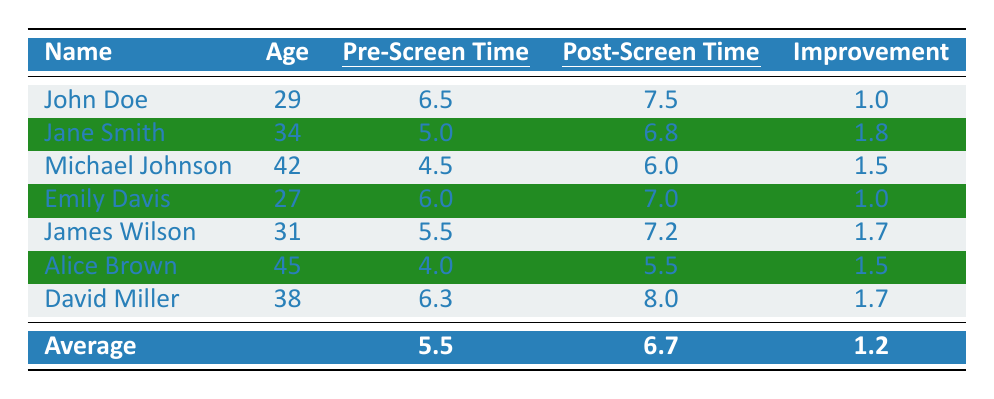What is the average pre-screen time among the participants? To find the average pre-screen time, you add all the pre-screen time values: 6.5 + 5.0 + 4.5 + 6.0 + 5.5 + 4.0 + 6.3 = 37.8. Then divide by the number of participants (7): 37.8 / 7 = 5.4.
Answer: 5.4 What is the maximum post-screen time recorded? The post-screen times are 7.5, 6.8, 6.0, 7.0, 7.2, 5.5, and 8.0. The maximum value among these is 8.0.
Answer: 8.0 Which participant showed the greatest improvement in sleep hours? The improvements are: John Doe 1.0, Jane Smith 1.8, Michael Johnson 1.5, Emily Davis 1.0, James Wilson 1.7, Alice Brown 1.5, David Miller 1.7. Jane Smith has the greatest improvement at 1.8.
Answer: Jane Smith What was the average improvement in sleep hours for all participants? To calculate the average improvement, add up the improvements: 1.0 + 1.8 + 1.5 + 1.0 + 1.7 + 1.5 + 1.7 = 10.2. Then divide by the number of participants (7): 10.2 / 7 = 1.46.
Answer: 1.46 Did all participants experience an increase in their sleep hours after the screen time limitation? Comparing pre and post-screen times, all participants have higher post-screen times than pre-screen times; hence, yes, all experienced an increase.
Answer: Yes Is there any participant who had a pre-screen time less than 5 hours? Alice Brown had a pre-screen time of 4.0, which is less than 5 hours.
Answer: Yes Calculate the total improvement in sleep hours from all participants combined. The total improvement is found by summing up each participant's improvement: 1.0 + 1.8 + 1.5 + 1.0 + 1.7 + 1.5 + 1.7 = 10.2.
Answer: 10.2 Which participant had the closest improvement to the average improvement of 1.2 hours? The improvements are: 1.0, 1.8, 1.5, 1.0, 1.7, 1.5, and 1.7. The closest improvement to 1.2 is John Doe (1.0).
Answer: John Doe What is the average post-screen time for participants aged 30 or older? The eligible participants are Jane Smith (6.8), Michael Johnson (6.0), Alice Brown (5.5), and David Miller (8.0). Their average is (6.8 + 6.0 + 5.5 + 8.0) / 4 = 6.33.
Answer: 6.33 How many participants improved their sleep by more than 1.5 hours? The improvements over 1.5 hours are: Jane Smith (1.8), James Wilson (1.7), David Miller (1.7). This makes a total of 3 participants.
Answer: 3 